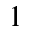Convert formula to latex. <formula><loc_0><loc_0><loc_500><loc_500>1</formula> 